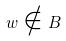<formula> <loc_0><loc_0><loc_500><loc_500>w \notin B</formula> 